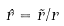<formula> <loc_0><loc_0><loc_500><loc_500>\hat { r } = \vec { r } / r</formula> 